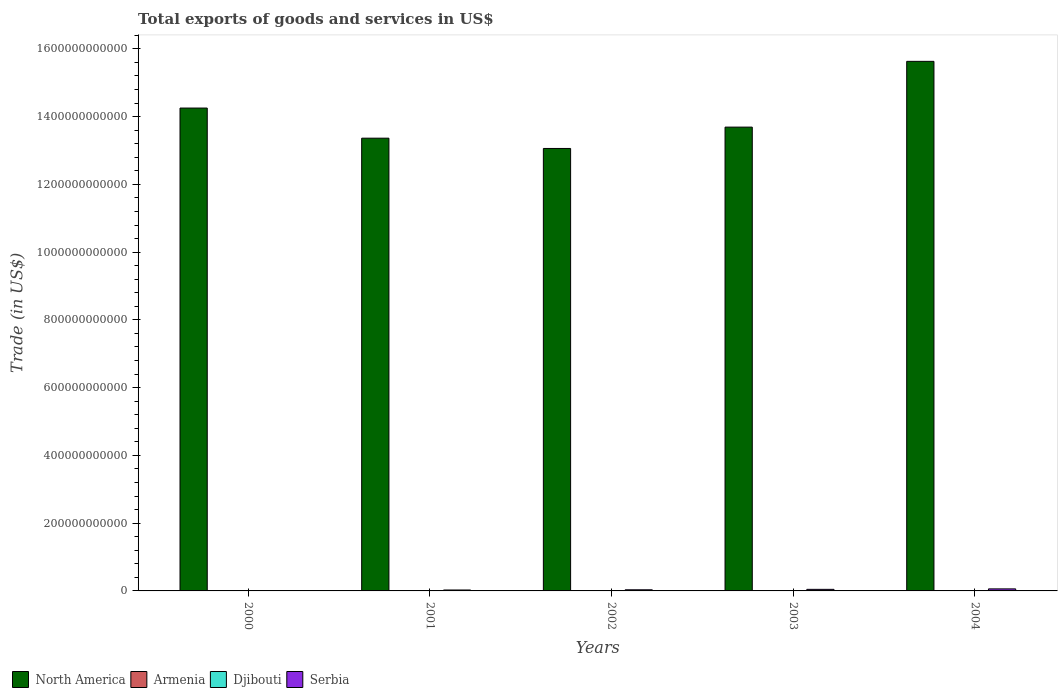Are the number of bars per tick equal to the number of legend labels?
Give a very brief answer. Yes. Are the number of bars on each tick of the X-axis equal?
Provide a succinct answer. Yes. What is the total exports of goods and services in North America in 2003?
Your answer should be compact. 1.37e+12. Across all years, what is the maximum total exports of goods and services in Djibouti?
Keep it short and to the point. 2.48e+08. Across all years, what is the minimum total exports of goods and services in Armenia?
Offer a terse response. 4.47e+08. In which year was the total exports of goods and services in Djibouti minimum?
Your answer should be compact. 2000. What is the total total exports of goods and services in North America in the graph?
Provide a succinct answer. 7.00e+12. What is the difference between the total exports of goods and services in North America in 2000 and that in 2002?
Your answer should be compact. 1.19e+11. What is the difference between the total exports of goods and services in Serbia in 2001 and the total exports of goods and services in Armenia in 2004?
Ensure brevity in your answer.  1.69e+09. What is the average total exports of goods and services in Djibouti per year?
Your answer should be very brief. 2.26e+08. In the year 2004, what is the difference between the total exports of goods and services in Armenia and total exports of goods and services in Djibouti?
Your answer should be very brief. 8.17e+08. In how many years, is the total exports of goods and services in Serbia greater than 440000000000 US$?
Make the answer very short. 0. What is the ratio of the total exports of goods and services in North America in 2003 to that in 2004?
Your response must be concise. 0.88. Is the difference between the total exports of goods and services in Armenia in 2001 and 2003 greater than the difference between the total exports of goods and services in Djibouti in 2001 and 2003?
Your response must be concise. No. What is the difference between the highest and the second highest total exports of goods and services in Serbia?
Ensure brevity in your answer.  1.37e+09. What is the difference between the highest and the lowest total exports of goods and services in Serbia?
Keep it short and to the point. 5.38e+09. In how many years, is the total exports of goods and services in Djibouti greater than the average total exports of goods and services in Djibouti taken over all years?
Your answer should be very brief. 3. Is the sum of the total exports of goods and services in North America in 2002 and 2003 greater than the maximum total exports of goods and services in Serbia across all years?
Your answer should be compact. Yes. Is it the case that in every year, the sum of the total exports of goods and services in Djibouti and total exports of goods and services in North America is greater than the sum of total exports of goods and services in Serbia and total exports of goods and services in Armenia?
Your response must be concise. Yes. What does the 3rd bar from the left in 2003 represents?
Give a very brief answer. Djibouti. What does the 2nd bar from the right in 2003 represents?
Ensure brevity in your answer.  Djibouti. Is it the case that in every year, the sum of the total exports of goods and services in Djibouti and total exports of goods and services in Armenia is greater than the total exports of goods and services in North America?
Offer a terse response. No. How many bars are there?
Offer a terse response. 20. How many years are there in the graph?
Keep it short and to the point. 5. What is the difference between two consecutive major ticks on the Y-axis?
Provide a short and direct response. 2.00e+11. Does the graph contain any zero values?
Offer a terse response. No. How are the legend labels stacked?
Offer a very short reply. Horizontal. What is the title of the graph?
Your response must be concise. Total exports of goods and services in US$. Does "Bhutan" appear as one of the legend labels in the graph?
Keep it short and to the point. No. What is the label or title of the X-axis?
Provide a short and direct response. Years. What is the label or title of the Y-axis?
Provide a succinct answer. Trade (in US$). What is the Trade (in US$) in North America in 2000?
Provide a succinct answer. 1.43e+12. What is the Trade (in US$) in Armenia in 2000?
Provide a succinct answer. 4.47e+08. What is the Trade (in US$) of Djibouti in 2000?
Keep it short and to the point. 1.93e+08. What is the Trade (in US$) in Serbia in 2000?
Offer a very short reply. 6.44e+08. What is the Trade (in US$) in North America in 2001?
Provide a succinct answer. 1.34e+12. What is the Trade (in US$) in Armenia in 2001?
Give a very brief answer. 5.40e+08. What is the Trade (in US$) in Djibouti in 2001?
Offer a very short reply. 2.13e+08. What is the Trade (in US$) in Serbia in 2001?
Make the answer very short. 2.75e+09. What is the Trade (in US$) in North America in 2002?
Your answer should be compact. 1.31e+12. What is the Trade (in US$) of Armenia in 2002?
Offer a terse response. 6.98e+08. What is the Trade (in US$) of Djibouti in 2002?
Your answer should be very brief. 2.28e+08. What is the Trade (in US$) in Serbia in 2002?
Provide a short and direct response. 3.33e+09. What is the Trade (in US$) in North America in 2003?
Keep it short and to the point. 1.37e+12. What is the Trade (in US$) in Armenia in 2003?
Ensure brevity in your answer.  9.03e+08. What is the Trade (in US$) of Djibouti in 2003?
Provide a succinct answer. 2.48e+08. What is the Trade (in US$) of Serbia in 2003?
Give a very brief answer. 4.65e+09. What is the Trade (in US$) of North America in 2004?
Provide a succinct answer. 1.56e+12. What is the Trade (in US$) in Armenia in 2004?
Provide a succinct answer. 1.06e+09. What is the Trade (in US$) of Djibouti in 2004?
Offer a very short reply. 2.46e+08. What is the Trade (in US$) in Serbia in 2004?
Give a very brief answer. 6.02e+09. Across all years, what is the maximum Trade (in US$) in North America?
Keep it short and to the point. 1.56e+12. Across all years, what is the maximum Trade (in US$) in Armenia?
Ensure brevity in your answer.  1.06e+09. Across all years, what is the maximum Trade (in US$) in Djibouti?
Offer a terse response. 2.48e+08. Across all years, what is the maximum Trade (in US$) in Serbia?
Make the answer very short. 6.02e+09. Across all years, what is the minimum Trade (in US$) of North America?
Ensure brevity in your answer.  1.31e+12. Across all years, what is the minimum Trade (in US$) of Armenia?
Your response must be concise. 4.47e+08. Across all years, what is the minimum Trade (in US$) in Djibouti?
Provide a short and direct response. 1.93e+08. Across all years, what is the minimum Trade (in US$) of Serbia?
Your answer should be compact. 6.44e+08. What is the total Trade (in US$) of North America in the graph?
Ensure brevity in your answer.  7.00e+12. What is the total Trade (in US$) of Armenia in the graph?
Provide a short and direct response. 3.65e+09. What is the total Trade (in US$) of Djibouti in the graph?
Keep it short and to the point. 1.13e+09. What is the total Trade (in US$) of Serbia in the graph?
Ensure brevity in your answer.  1.74e+1. What is the difference between the Trade (in US$) in North America in 2000 and that in 2001?
Your response must be concise. 8.90e+1. What is the difference between the Trade (in US$) in Armenia in 2000 and that in 2001?
Make the answer very short. -9.27e+07. What is the difference between the Trade (in US$) of Djibouti in 2000 and that in 2001?
Give a very brief answer. -2.02e+07. What is the difference between the Trade (in US$) in Serbia in 2000 and that in 2001?
Make the answer very short. -2.11e+09. What is the difference between the Trade (in US$) of North America in 2000 and that in 2002?
Keep it short and to the point. 1.19e+11. What is the difference between the Trade (in US$) of Armenia in 2000 and that in 2002?
Make the answer very short. -2.51e+08. What is the difference between the Trade (in US$) in Djibouti in 2000 and that in 2002?
Keep it short and to the point. -3.48e+07. What is the difference between the Trade (in US$) in Serbia in 2000 and that in 2002?
Your answer should be compact. -2.68e+09. What is the difference between the Trade (in US$) in North America in 2000 and that in 2003?
Your answer should be very brief. 5.63e+1. What is the difference between the Trade (in US$) of Armenia in 2000 and that in 2003?
Offer a very short reply. -4.56e+08. What is the difference between the Trade (in US$) in Djibouti in 2000 and that in 2003?
Provide a short and direct response. -5.50e+07. What is the difference between the Trade (in US$) of Serbia in 2000 and that in 2003?
Give a very brief answer. -4.01e+09. What is the difference between the Trade (in US$) of North America in 2000 and that in 2004?
Make the answer very short. -1.38e+11. What is the difference between the Trade (in US$) of Armenia in 2000 and that in 2004?
Your answer should be compact. -6.17e+08. What is the difference between the Trade (in US$) of Djibouti in 2000 and that in 2004?
Offer a terse response. -5.30e+07. What is the difference between the Trade (in US$) of Serbia in 2000 and that in 2004?
Your response must be concise. -5.38e+09. What is the difference between the Trade (in US$) of North America in 2001 and that in 2002?
Your answer should be compact. 3.03e+1. What is the difference between the Trade (in US$) in Armenia in 2001 and that in 2002?
Give a very brief answer. -1.58e+08. What is the difference between the Trade (in US$) in Djibouti in 2001 and that in 2002?
Your answer should be very brief. -1.45e+07. What is the difference between the Trade (in US$) of Serbia in 2001 and that in 2002?
Keep it short and to the point. -5.74e+08. What is the difference between the Trade (in US$) of North America in 2001 and that in 2003?
Your answer should be very brief. -3.27e+1. What is the difference between the Trade (in US$) of Armenia in 2001 and that in 2003?
Give a very brief answer. -3.63e+08. What is the difference between the Trade (in US$) of Djibouti in 2001 and that in 2003?
Keep it short and to the point. -3.48e+07. What is the difference between the Trade (in US$) of Serbia in 2001 and that in 2003?
Make the answer very short. -1.90e+09. What is the difference between the Trade (in US$) in North America in 2001 and that in 2004?
Your answer should be very brief. -2.27e+11. What is the difference between the Trade (in US$) of Armenia in 2001 and that in 2004?
Your answer should be compact. -5.24e+08. What is the difference between the Trade (in US$) of Djibouti in 2001 and that in 2004?
Offer a very short reply. -3.28e+07. What is the difference between the Trade (in US$) of Serbia in 2001 and that in 2004?
Give a very brief answer. -3.27e+09. What is the difference between the Trade (in US$) in North America in 2002 and that in 2003?
Make the answer very short. -6.30e+1. What is the difference between the Trade (in US$) of Armenia in 2002 and that in 2003?
Offer a terse response. -2.05e+08. What is the difference between the Trade (in US$) in Djibouti in 2002 and that in 2003?
Your answer should be very brief. -2.03e+07. What is the difference between the Trade (in US$) of Serbia in 2002 and that in 2003?
Your answer should be compact. -1.33e+09. What is the difference between the Trade (in US$) of North America in 2002 and that in 2004?
Provide a short and direct response. -2.57e+11. What is the difference between the Trade (in US$) of Armenia in 2002 and that in 2004?
Give a very brief answer. -3.66e+08. What is the difference between the Trade (in US$) of Djibouti in 2002 and that in 2004?
Your response must be concise. -1.82e+07. What is the difference between the Trade (in US$) of Serbia in 2002 and that in 2004?
Give a very brief answer. -2.69e+09. What is the difference between the Trade (in US$) in North America in 2003 and that in 2004?
Ensure brevity in your answer.  -1.94e+11. What is the difference between the Trade (in US$) in Armenia in 2003 and that in 2004?
Offer a terse response. -1.61e+08. What is the difference between the Trade (in US$) in Djibouti in 2003 and that in 2004?
Provide a short and direct response. 2.02e+06. What is the difference between the Trade (in US$) of Serbia in 2003 and that in 2004?
Your response must be concise. -1.37e+09. What is the difference between the Trade (in US$) in North America in 2000 and the Trade (in US$) in Armenia in 2001?
Offer a terse response. 1.42e+12. What is the difference between the Trade (in US$) in North America in 2000 and the Trade (in US$) in Djibouti in 2001?
Keep it short and to the point. 1.43e+12. What is the difference between the Trade (in US$) of North America in 2000 and the Trade (in US$) of Serbia in 2001?
Offer a very short reply. 1.42e+12. What is the difference between the Trade (in US$) of Armenia in 2000 and the Trade (in US$) of Djibouti in 2001?
Give a very brief answer. 2.33e+08. What is the difference between the Trade (in US$) in Armenia in 2000 and the Trade (in US$) in Serbia in 2001?
Your response must be concise. -2.31e+09. What is the difference between the Trade (in US$) in Djibouti in 2000 and the Trade (in US$) in Serbia in 2001?
Offer a terse response. -2.56e+09. What is the difference between the Trade (in US$) in North America in 2000 and the Trade (in US$) in Armenia in 2002?
Your response must be concise. 1.42e+12. What is the difference between the Trade (in US$) in North America in 2000 and the Trade (in US$) in Djibouti in 2002?
Offer a very short reply. 1.43e+12. What is the difference between the Trade (in US$) in North America in 2000 and the Trade (in US$) in Serbia in 2002?
Make the answer very short. 1.42e+12. What is the difference between the Trade (in US$) in Armenia in 2000 and the Trade (in US$) in Djibouti in 2002?
Provide a short and direct response. 2.19e+08. What is the difference between the Trade (in US$) in Armenia in 2000 and the Trade (in US$) in Serbia in 2002?
Give a very brief answer. -2.88e+09. What is the difference between the Trade (in US$) of Djibouti in 2000 and the Trade (in US$) of Serbia in 2002?
Your response must be concise. -3.13e+09. What is the difference between the Trade (in US$) of North America in 2000 and the Trade (in US$) of Armenia in 2003?
Your answer should be very brief. 1.42e+12. What is the difference between the Trade (in US$) in North America in 2000 and the Trade (in US$) in Djibouti in 2003?
Give a very brief answer. 1.43e+12. What is the difference between the Trade (in US$) of North America in 2000 and the Trade (in US$) of Serbia in 2003?
Keep it short and to the point. 1.42e+12. What is the difference between the Trade (in US$) of Armenia in 2000 and the Trade (in US$) of Djibouti in 2003?
Give a very brief answer. 1.99e+08. What is the difference between the Trade (in US$) of Armenia in 2000 and the Trade (in US$) of Serbia in 2003?
Offer a terse response. -4.21e+09. What is the difference between the Trade (in US$) in Djibouti in 2000 and the Trade (in US$) in Serbia in 2003?
Your answer should be very brief. -4.46e+09. What is the difference between the Trade (in US$) in North America in 2000 and the Trade (in US$) in Armenia in 2004?
Keep it short and to the point. 1.42e+12. What is the difference between the Trade (in US$) of North America in 2000 and the Trade (in US$) of Djibouti in 2004?
Your response must be concise. 1.43e+12. What is the difference between the Trade (in US$) in North America in 2000 and the Trade (in US$) in Serbia in 2004?
Give a very brief answer. 1.42e+12. What is the difference between the Trade (in US$) of Armenia in 2000 and the Trade (in US$) of Djibouti in 2004?
Your response must be concise. 2.01e+08. What is the difference between the Trade (in US$) of Armenia in 2000 and the Trade (in US$) of Serbia in 2004?
Your response must be concise. -5.57e+09. What is the difference between the Trade (in US$) in Djibouti in 2000 and the Trade (in US$) in Serbia in 2004?
Your response must be concise. -5.83e+09. What is the difference between the Trade (in US$) of North America in 2001 and the Trade (in US$) of Armenia in 2002?
Your response must be concise. 1.34e+12. What is the difference between the Trade (in US$) of North America in 2001 and the Trade (in US$) of Djibouti in 2002?
Give a very brief answer. 1.34e+12. What is the difference between the Trade (in US$) of North America in 2001 and the Trade (in US$) of Serbia in 2002?
Make the answer very short. 1.33e+12. What is the difference between the Trade (in US$) of Armenia in 2001 and the Trade (in US$) of Djibouti in 2002?
Give a very brief answer. 3.12e+08. What is the difference between the Trade (in US$) in Armenia in 2001 and the Trade (in US$) in Serbia in 2002?
Your response must be concise. -2.79e+09. What is the difference between the Trade (in US$) of Djibouti in 2001 and the Trade (in US$) of Serbia in 2002?
Provide a short and direct response. -3.11e+09. What is the difference between the Trade (in US$) in North America in 2001 and the Trade (in US$) in Armenia in 2003?
Ensure brevity in your answer.  1.34e+12. What is the difference between the Trade (in US$) of North America in 2001 and the Trade (in US$) of Djibouti in 2003?
Offer a terse response. 1.34e+12. What is the difference between the Trade (in US$) in North America in 2001 and the Trade (in US$) in Serbia in 2003?
Offer a terse response. 1.33e+12. What is the difference between the Trade (in US$) of Armenia in 2001 and the Trade (in US$) of Djibouti in 2003?
Give a very brief answer. 2.91e+08. What is the difference between the Trade (in US$) of Armenia in 2001 and the Trade (in US$) of Serbia in 2003?
Give a very brief answer. -4.11e+09. What is the difference between the Trade (in US$) in Djibouti in 2001 and the Trade (in US$) in Serbia in 2003?
Make the answer very short. -4.44e+09. What is the difference between the Trade (in US$) of North America in 2001 and the Trade (in US$) of Armenia in 2004?
Your answer should be compact. 1.34e+12. What is the difference between the Trade (in US$) of North America in 2001 and the Trade (in US$) of Djibouti in 2004?
Provide a succinct answer. 1.34e+12. What is the difference between the Trade (in US$) of North America in 2001 and the Trade (in US$) of Serbia in 2004?
Keep it short and to the point. 1.33e+12. What is the difference between the Trade (in US$) of Armenia in 2001 and the Trade (in US$) of Djibouti in 2004?
Your answer should be very brief. 2.93e+08. What is the difference between the Trade (in US$) of Armenia in 2001 and the Trade (in US$) of Serbia in 2004?
Your answer should be compact. -5.48e+09. What is the difference between the Trade (in US$) in Djibouti in 2001 and the Trade (in US$) in Serbia in 2004?
Your response must be concise. -5.81e+09. What is the difference between the Trade (in US$) of North America in 2002 and the Trade (in US$) of Armenia in 2003?
Offer a terse response. 1.31e+12. What is the difference between the Trade (in US$) of North America in 2002 and the Trade (in US$) of Djibouti in 2003?
Offer a very short reply. 1.31e+12. What is the difference between the Trade (in US$) in North America in 2002 and the Trade (in US$) in Serbia in 2003?
Your answer should be very brief. 1.30e+12. What is the difference between the Trade (in US$) of Armenia in 2002 and the Trade (in US$) of Djibouti in 2003?
Offer a very short reply. 4.49e+08. What is the difference between the Trade (in US$) in Armenia in 2002 and the Trade (in US$) in Serbia in 2003?
Offer a very short reply. -3.96e+09. What is the difference between the Trade (in US$) in Djibouti in 2002 and the Trade (in US$) in Serbia in 2003?
Provide a succinct answer. -4.43e+09. What is the difference between the Trade (in US$) of North America in 2002 and the Trade (in US$) of Armenia in 2004?
Keep it short and to the point. 1.30e+12. What is the difference between the Trade (in US$) in North America in 2002 and the Trade (in US$) in Djibouti in 2004?
Offer a very short reply. 1.31e+12. What is the difference between the Trade (in US$) of North America in 2002 and the Trade (in US$) of Serbia in 2004?
Provide a succinct answer. 1.30e+12. What is the difference between the Trade (in US$) of Armenia in 2002 and the Trade (in US$) of Djibouti in 2004?
Give a very brief answer. 4.51e+08. What is the difference between the Trade (in US$) in Armenia in 2002 and the Trade (in US$) in Serbia in 2004?
Make the answer very short. -5.32e+09. What is the difference between the Trade (in US$) of Djibouti in 2002 and the Trade (in US$) of Serbia in 2004?
Keep it short and to the point. -5.79e+09. What is the difference between the Trade (in US$) in North America in 2003 and the Trade (in US$) in Armenia in 2004?
Keep it short and to the point. 1.37e+12. What is the difference between the Trade (in US$) of North America in 2003 and the Trade (in US$) of Djibouti in 2004?
Make the answer very short. 1.37e+12. What is the difference between the Trade (in US$) in North America in 2003 and the Trade (in US$) in Serbia in 2004?
Offer a terse response. 1.36e+12. What is the difference between the Trade (in US$) of Armenia in 2003 and the Trade (in US$) of Djibouti in 2004?
Your response must be concise. 6.56e+08. What is the difference between the Trade (in US$) in Armenia in 2003 and the Trade (in US$) in Serbia in 2004?
Your answer should be very brief. -5.12e+09. What is the difference between the Trade (in US$) in Djibouti in 2003 and the Trade (in US$) in Serbia in 2004?
Give a very brief answer. -5.77e+09. What is the average Trade (in US$) of North America per year?
Your answer should be compact. 1.40e+12. What is the average Trade (in US$) of Armenia per year?
Provide a short and direct response. 7.30e+08. What is the average Trade (in US$) in Djibouti per year?
Offer a terse response. 2.26e+08. What is the average Trade (in US$) in Serbia per year?
Give a very brief answer. 3.48e+09. In the year 2000, what is the difference between the Trade (in US$) in North America and Trade (in US$) in Armenia?
Provide a short and direct response. 1.42e+12. In the year 2000, what is the difference between the Trade (in US$) of North America and Trade (in US$) of Djibouti?
Your answer should be compact. 1.43e+12. In the year 2000, what is the difference between the Trade (in US$) in North America and Trade (in US$) in Serbia?
Give a very brief answer. 1.42e+12. In the year 2000, what is the difference between the Trade (in US$) in Armenia and Trade (in US$) in Djibouti?
Provide a short and direct response. 2.54e+08. In the year 2000, what is the difference between the Trade (in US$) of Armenia and Trade (in US$) of Serbia?
Your answer should be compact. -1.98e+08. In the year 2000, what is the difference between the Trade (in US$) of Djibouti and Trade (in US$) of Serbia?
Provide a short and direct response. -4.51e+08. In the year 2001, what is the difference between the Trade (in US$) of North America and Trade (in US$) of Armenia?
Provide a short and direct response. 1.34e+12. In the year 2001, what is the difference between the Trade (in US$) of North America and Trade (in US$) of Djibouti?
Offer a very short reply. 1.34e+12. In the year 2001, what is the difference between the Trade (in US$) in North America and Trade (in US$) in Serbia?
Keep it short and to the point. 1.33e+12. In the year 2001, what is the difference between the Trade (in US$) in Armenia and Trade (in US$) in Djibouti?
Your response must be concise. 3.26e+08. In the year 2001, what is the difference between the Trade (in US$) of Armenia and Trade (in US$) of Serbia?
Provide a succinct answer. -2.21e+09. In the year 2001, what is the difference between the Trade (in US$) of Djibouti and Trade (in US$) of Serbia?
Provide a succinct answer. -2.54e+09. In the year 2002, what is the difference between the Trade (in US$) of North America and Trade (in US$) of Armenia?
Give a very brief answer. 1.31e+12. In the year 2002, what is the difference between the Trade (in US$) in North America and Trade (in US$) in Djibouti?
Ensure brevity in your answer.  1.31e+12. In the year 2002, what is the difference between the Trade (in US$) of North America and Trade (in US$) of Serbia?
Make the answer very short. 1.30e+12. In the year 2002, what is the difference between the Trade (in US$) of Armenia and Trade (in US$) of Djibouti?
Give a very brief answer. 4.70e+08. In the year 2002, what is the difference between the Trade (in US$) in Armenia and Trade (in US$) in Serbia?
Provide a short and direct response. -2.63e+09. In the year 2002, what is the difference between the Trade (in US$) in Djibouti and Trade (in US$) in Serbia?
Your answer should be compact. -3.10e+09. In the year 2003, what is the difference between the Trade (in US$) in North America and Trade (in US$) in Armenia?
Ensure brevity in your answer.  1.37e+12. In the year 2003, what is the difference between the Trade (in US$) of North America and Trade (in US$) of Djibouti?
Your answer should be very brief. 1.37e+12. In the year 2003, what is the difference between the Trade (in US$) of North America and Trade (in US$) of Serbia?
Keep it short and to the point. 1.36e+12. In the year 2003, what is the difference between the Trade (in US$) of Armenia and Trade (in US$) of Djibouti?
Provide a succinct answer. 6.54e+08. In the year 2003, what is the difference between the Trade (in US$) of Armenia and Trade (in US$) of Serbia?
Keep it short and to the point. -3.75e+09. In the year 2003, what is the difference between the Trade (in US$) of Djibouti and Trade (in US$) of Serbia?
Offer a terse response. -4.41e+09. In the year 2004, what is the difference between the Trade (in US$) in North America and Trade (in US$) in Armenia?
Keep it short and to the point. 1.56e+12. In the year 2004, what is the difference between the Trade (in US$) of North America and Trade (in US$) of Djibouti?
Offer a very short reply. 1.56e+12. In the year 2004, what is the difference between the Trade (in US$) of North America and Trade (in US$) of Serbia?
Offer a terse response. 1.56e+12. In the year 2004, what is the difference between the Trade (in US$) in Armenia and Trade (in US$) in Djibouti?
Offer a terse response. 8.17e+08. In the year 2004, what is the difference between the Trade (in US$) of Armenia and Trade (in US$) of Serbia?
Your response must be concise. -4.96e+09. In the year 2004, what is the difference between the Trade (in US$) in Djibouti and Trade (in US$) in Serbia?
Offer a terse response. -5.78e+09. What is the ratio of the Trade (in US$) of North America in 2000 to that in 2001?
Your answer should be very brief. 1.07. What is the ratio of the Trade (in US$) in Armenia in 2000 to that in 2001?
Give a very brief answer. 0.83. What is the ratio of the Trade (in US$) in Djibouti in 2000 to that in 2001?
Give a very brief answer. 0.91. What is the ratio of the Trade (in US$) in Serbia in 2000 to that in 2001?
Your answer should be very brief. 0.23. What is the ratio of the Trade (in US$) in North America in 2000 to that in 2002?
Ensure brevity in your answer.  1.09. What is the ratio of the Trade (in US$) of Armenia in 2000 to that in 2002?
Provide a succinct answer. 0.64. What is the ratio of the Trade (in US$) in Djibouti in 2000 to that in 2002?
Your answer should be compact. 0.85. What is the ratio of the Trade (in US$) of Serbia in 2000 to that in 2002?
Your response must be concise. 0.19. What is the ratio of the Trade (in US$) of North America in 2000 to that in 2003?
Ensure brevity in your answer.  1.04. What is the ratio of the Trade (in US$) in Armenia in 2000 to that in 2003?
Ensure brevity in your answer.  0.5. What is the ratio of the Trade (in US$) of Djibouti in 2000 to that in 2003?
Provide a succinct answer. 0.78. What is the ratio of the Trade (in US$) of Serbia in 2000 to that in 2003?
Offer a very short reply. 0.14. What is the ratio of the Trade (in US$) in North America in 2000 to that in 2004?
Your response must be concise. 0.91. What is the ratio of the Trade (in US$) of Armenia in 2000 to that in 2004?
Offer a terse response. 0.42. What is the ratio of the Trade (in US$) of Djibouti in 2000 to that in 2004?
Your answer should be compact. 0.78. What is the ratio of the Trade (in US$) in Serbia in 2000 to that in 2004?
Offer a terse response. 0.11. What is the ratio of the Trade (in US$) in North America in 2001 to that in 2002?
Make the answer very short. 1.02. What is the ratio of the Trade (in US$) of Armenia in 2001 to that in 2002?
Offer a terse response. 0.77. What is the ratio of the Trade (in US$) of Djibouti in 2001 to that in 2002?
Your answer should be compact. 0.94. What is the ratio of the Trade (in US$) of Serbia in 2001 to that in 2002?
Make the answer very short. 0.83. What is the ratio of the Trade (in US$) of North America in 2001 to that in 2003?
Make the answer very short. 0.98. What is the ratio of the Trade (in US$) in Armenia in 2001 to that in 2003?
Keep it short and to the point. 0.6. What is the ratio of the Trade (in US$) in Djibouti in 2001 to that in 2003?
Your answer should be very brief. 0.86. What is the ratio of the Trade (in US$) of Serbia in 2001 to that in 2003?
Your answer should be very brief. 0.59. What is the ratio of the Trade (in US$) in North America in 2001 to that in 2004?
Provide a succinct answer. 0.85. What is the ratio of the Trade (in US$) in Armenia in 2001 to that in 2004?
Provide a succinct answer. 0.51. What is the ratio of the Trade (in US$) in Djibouti in 2001 to that in 2004?
Keep it short and to the point. 0.87. What is the ratio of the Trade (in US$) of Serbia in 2001 to that in 2004?
Provide a short and direct response. 0.46. What is the ratio of the Trade (in US$) of North America in 2002 to that in 2003?
Ensure brevity in your answer.  0.95. What is the ratio of the Trade (in US$) in Armenia in 2002 to that in 2003?
Provide a short and direct response. 0.77. What is the ratio of the Trade (in US$) in Djibouti in 2002 to that in 2003?
Provide a succinct answer. 0.92. What is the ratio of the Trade (in US$) of Serbia in 2002 to that in 2003?
Offer a terse response. 0.71. What is the ratio of the Trade (in US$) in North America in 2002 to that in 2004?
Ensure brevity in your answer.  0.84. What is the ratio of the Trade (in US$) in Armenia in 2002 to that in 2004?
Provide a short and direct response. 0.66. What is the ratio of the Trade (in US$) in Djibouti in 2002 to that in 2004?
Make the answer very short. 0.93. What is the ratio of the Trade (in US$) in Serbia in 2002 to that in 2004?
Provide a short and direct response. 0.55. What is the ratio of the Trade (in US$) in North America in 2003 to that in 2004?
Provide a succinct answer. 0.88. What is the ratio of the Trade (in US$) in Armenia in 2003 to that in 2004?
Your response must be concise. 0.85. What is the ratio of the Trade (in US$) of Djibouti in 2003 to that in 2004?
Keep it short and to the point. 1.01. What is the ratio of the Trade (in US$) in Serbia in 2003 to that in 2004?
Keep it short and to the point. 0.77. What is the difference between the highest and the second highest Trade (in US$) of North America?
Give a very brief answer. 1.38e+11. What is the difference between the highest and the second highest Trade (in US$) of Armenia?
Offer a terse response. 1.61e+08. What is the difference between the highest and the second highest Trade (in US$) of Djibouti?
Make the answer very short. 2.02e+06. What is the difference between the highest and the second highest Trade (in US$) in Serbia?
Offer a very short reply. 1.37e+09. What is the difference between the highest and the lowest Trade (in US$) in North America?
Give a very brief answer. 2.57e+11. What is the difference between the highest and the lowest Trade (in US$) in Armenia?
Your response must be concise. 6.17e+08. What is the difference between the highest and the lowest Trade (in US$) in Djibouti?
Ensure brevity in your answer.  5.50e+07. What is the difference between the highest and the lowest Trade (in US$) in Serbia?
Provide a succinct answer. 5.38e+09. 